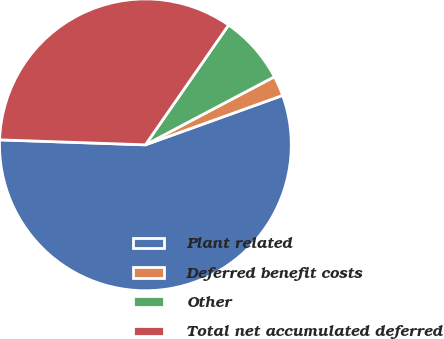Convert chart. <chart><loc_0><loc_0><loc_500><loc_500><pie_chart><fcel>Plant related<fcel>Deferred benefit costs<fcel>Other<fcel>Total net accumulated deferred<nl><fcel>56.04%<fcel>2.23%<fcel>7.61%<fcel>34.11%<nl></chart> 